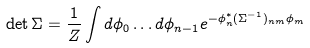Convert formula to latex. <formula><loc_0><loc_0><loc_500><loc_500>\det \Sigma = \frac { 1 } { Z } \int d \phi _ { 0 } \dots d \phi _ { n - 1 } e ^ { - \phi _ { n } ^ { \ast } ( \Sigma ^ { - 1 } ) _ { n m } \phi _ { m } }</formula> 